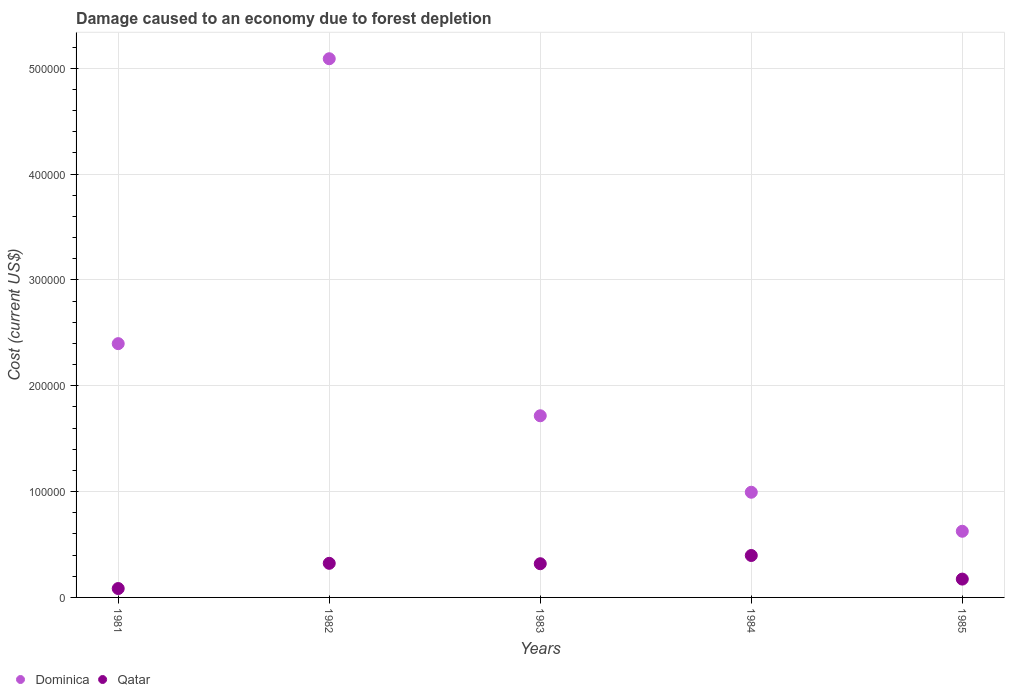How many different coloured dotlines are there?
Offer a very short reply. 2. What is the cost of damage caused due to forest depletion in Dominica in 1985?
Offer a very short reply. 6.25e+04. Across all years, what is the maximum cost of damage caused due to forest depletion in Dominica?
Your answer should be compact. 5.09e+05. Across all years, what is the minimum cost of damage caused due to forest depletion in Qatar?
Give a very brief answer. 8396.44. In which year was the cost of damage caused due to forest depletion in Qatar maximum?
Make the answer very short. 1984. In which year was the cost of damage caused due to forest depletion in Qatar minimum?
Your answer should be compact. 1981. What is the total cost of damage caused due to forest depletion in Dominica in the graph?
Your answer should be compact. 1.08e+06. What is the difference between the cost of damage caused due to forest depletion in Qatar in 1981 and that in 1985?
Offer a very short reply. -8924.05. What is the difference between the cost of damage caused due to forest depletion in Qatar in 1983 and the cost of damage caused due to forest depletion in Dominica in 1981?
Provide a short and direct response. -2.08e+05. What is the average cost of damage caused due to forest depletion in Qatar per year?
Provide a short and direct response. 2.59e+04. In the year 1981, what is the difference between the cost of damage caused due to forest depletion in Qatar and cost of damage caused due to forest depletion in Dominica?
Provide a succinct answer. -2.31e+05. What is the ratio of the cost of damage caused due to forest depletion in Qatar in 1981 to that in 1983?
Your answer should be compact. 0.26. Is the cost of damage caused due to forest depletion in Qatar in 1981 less than that in 1985?
Your answer should be compact. Yes. Is the difference between the cost of damage caused due to forest depletion in Qatar in 1981 and 1985 greater than the difference between the cost of damage caused due to forest depletion in Dominica in 1981 and 1985?
Your answer should be very brief. No. What is the difference between the highest and the second highest cost of damage caused due to forest depletion in Dominica?
Provide a short and direct response. 2.69e+05. What is the difference between the highest and the lowest cost of damage caused due to forest depletion in Dominica?
Your answer should be very brief. 4.46e+05. Is the sum of the cost of damage caused due to forest depletion in Qatar in 1981 and 1985 greater than the maximum cost of damage caused due to forest depletion in Dominica across all years?
Provide a short and direct response. No. Is the cost of damage caused due to forest depletion in Dominica strictly greater than the cost of damage caused due to forest depletion in Qatar over the years?
Keep it short and to the point. Yes. How many dotlines are there?
Ensure brevity in your answer.  2. How many years are there in the graph?
Your response must be concise. 5. How many legend labels are there?
Make the answer very short. 2. What is the title of the graph?
Give a very brief answer. Damage caused to an economy due to forest depletion. What is the label or title of the X-axis?
Your response must be concise. Years. What is the label or title of the Y-axis?
Provide a short and direct response. Cost (current US$). What is the Cost (current US$) of Dominica in 1981?
Give a very brief answer. 2.40e+05. What is the Cost (current US$) in Qatar in 1981?
Give a very brief answer. 8396.44. What is the Cost (current US$) in Dominica in 1982?
Provide a short and direct response. 5.09e+05. What is the Cost (current US$) in Qatar in 1982?
Provide a succinct answer. 3.22e+04. What is the Cost (current US$) of Dominica in 1983?
Provide a short and direct response. 1.72e+05. What is the Cost (current US$) of Qatar in 1983?
Offer a very short reply. 3.18e+04. What is the Cost (current US$) in Dominica in 1984?
Your answer should be compact. 9.94e+04. What is the Cost (current US$) in Qatar in 1984?
Offer a very short reply. 3.96e+04. What is the Cost (current US$) in Dominica in 1985?
Your answer should be very brief. 6.25e+04. What is the Cost (current US$) in Qatar in 1985?
Give a very brief answer. 1.73e+04. Across all years, what is the maximum Cost (current US$) in Dominica?
Offer a very short reply. 5.09e+05. Across all years, what is the maximum Cost (current US$) of Qatar?
Provide a succinct answer. 3.96e+04. Across all years, what is the minimum Cost (current US$) in Dominica?
Your answer should be very brief. 6.25e+04. Across all years, what is the minimum Cost (current US$) of Qatar?
Offer a very short reply. 8396.44. What is the total Cost (current US$) in Dominica in the graph?
Ensure brevity in your answer.  1.08e+06. What is the total Cost (current US$) in Qatar in the graph?
Provide a short and direct response. 1.29e+05. What is the difference between the Cost (current US$) in Dominica in 1981 and that in 1982?
Your answer should be very brief. -2.69e+05. What is the difference between the Cost (current US$) of Qatar in 1981 and that in 1982?
Provide a succinct answer. -2.38e+04. What is the difference between the Cost (current US$) in Dominica in 1981 and that in 1983?
Provide a short and direct response. 6.81e+04. What is the difference between the Cost (current US$) in Qatar in 1981 and that in 1983?
Offer a very short reply. -2.35e+04. What is the difference between the Cost (current US$) in Dominica in 1981 and that in 1984?
Make the answer very short. 1.40e+05. What is the difference between the Cost (current US$) in Qatar in 1981 and that in 1984?
Provide a short and direct response. -3.12e+04. What is the difference between the Cost (current US$) of Dominica in 1981 and that in 1985?
Ensure brevity in your answer.  1.77e+05. What is the difference between the Cost (current US$) of Qatar in 1981 and that in 1985?
Make the answer very short. -8924.05. What is the difference between the Cost (current US$) of Dominica in 1982 and that in 1983?
Your response must be concise. 3.37e+05. What is the difference between the Cost (current US$) in Qatar in 1982 and that in 1983?
Ensure brevity in your answer.  373.74. What is the difference between the Cost (current US$) in Dominica in 1982 and that in 1984?
Ensure brevity in your answer.  4.10e+05. What is the difference between the Cost (current US$) of Qatar in 1982 and that in 1984?
Your response must be concise. -7390.43. What is the difference between the Cost (current US$) of Dominica in 1982 and that in 1985?
Make the answer very short. 4.46e+05. What is the difference between the Cost (current US$) in Qatar in 1982 and that in 1985?
Provide a succinct answer. 1.49e+04. What is the difference between the Cost (current US$) in Dominica in 1983 and that in 1984?
Provide a succinct answer. 7.23e+04. What is the difference between the Cost (current US$) of Qatar in 1983 and that in 1984?
Offer a very short reply. -7764.17. What is the difference between the Cost (current US$) in Dominica in 1983 and that in 1985?
Keep it short and to the point. 1.09e+05. What is the difference between the Cost (current US$) in Qatar in 1983 and that in 1985?
Your answer should be compact. 1.45e+04. What is the difference between the Cost (current US$) of Dominica in 1984 and that in 1985?
Ensure brevity in your answer.  3.69e+04. What is the difference between the Cost (current US$) in Qatar in 1984 and that in 1985?
Provide a succinct answer. 2.23e+04. What is the difference between the Cost (current US$) in Dominica in 1981 and the Cost (current US$) in Qatar in 1982?
Your response must be concise. 2.08e+05. What is the difference between the Cost (current US$) of Dominica in 1981 and the Cost (current US$) of Qatar in 1983?
Offer a terse response. 2.08e+05. What is the difference between the Cost (current US$) of Dominica in 1981 and the Cost (current US$) of Qatar in 1984?
Ensure brevity in your answer.  2.00e+05. What is the difference between the Cost (current US$) in Dominica in 1981 and the Cost (current US$) in Qatar in 1985?
Your response must be concise. 2.22e+05. What is the difference between the Cost (current US$) of Dominica in 1982 and the Cost (current US$) of Qatar in 1983?
Provide a succinct answer. 4.77e+05. What is the difference between the Cost (current US$) of Dominica in 1982 and the Cost (current US$) of Qatar in 1984?
Your answer should be compact. 4.69e+05. What is the difference between the Cost (current US$) of Dominica in 1982 and the Cost (current US$) of Qatar in 1985?
Make the answer very short. 4.92e+05. What is the difference between the Cost (current US$) of Dominica in 1983 and the Cost (current US$) of Qatar in 1984?
Your answer should be very brief. 1.32e+05. What is the difference between the Cost (current US$) of Dominica in 1983 and the Cost (current US$) of Qatar in 1985?
Ensure brevity in your answer.  1.54e+05. What is the difference between the Cost (current US$) of Dominica in 1984 and the Cost (current US$) of Qatar in 1985?
Ensure brevity in your answer.  8.21e+04. What is the average Cost (current US$) of Dominica per year?
Your response must be concise. 2.16e+05. What is the average Cost (current US$) in Qatar per year?
Give a very brief answer. 2.59e+04. In the year 1981, what is the difference between the Cost (current US$) of Dominica and Cost (current US$) of Qatar?
Your answer should be compact. 2.31e+05. In the year 1982, what is the difference between the Cost (current US$) in Dominica and Cost (current US$) in Qatar?
Provide a succinct answer. 4.77e+05. In the year 1983, what is the difference between the Cost (current US$) of Dominica and Cost (current US$) of Qatar?
Give a very brief answer. 1.40e+05. In the year 1984, what is the difference between the Cost (current US$) of Dominica and Cost (current US$) of Qatar?
Your response must be concise. 5.98e+04. In the year 1985, what is the difference between the Cost (current US$) of Dominica and Cost (current US$) of Qatar?
Give a very brief answer. 4.52e+04. What is the ratio of the Cost (current US$) in Dominica in 1981 to that in 1982?
Make the answer very short. 0.47. What is the ratio of the Cost (current US$) in Qatar in 1981 to that in 1982?
Give a very brief answer. 0.26. What is the ratio of the Cost (current US$) of Dominica in 1981 to that in 1983?
Your answer should be very brief. 1.4. What is the ratio of the Cost (current US$) of Qatar in 1981 to that in 1983?
Give a very brief answer. 0.26. What is the ratio of the Cost (current US$) in Dominica in 1981 to that in 1984?
Provide a short and direct response. 2.41. What is the ratio of the Cost (current US$) in Qatar in 1981 to that in 1984?
Offer a very short reply. 0.21. What is the ratio of the Cost (current US$) in Dominica in 1981 to that in 1985?
Make the answer very short. 3.84. What is the ratio of the Cost (current US$) in Qatar in 1981 to that in 1985?
Offer a very short reply. 0.48. What is the ratio of the Cost (current US$) in Dominica in 1982 to that in 1983?
Provide a short and direct response. 2.97. What is the ratio of the Cost (current US$) of Qatar in 1982 to that in 1983?
Make the answer very short. 1.01. What is the ratio of the Cost (current US$) in Dominica in 1982 to that in 1984?
Your answer should be very brief. 5.12. What is the ratio of the Cost (current US$) in Qatar in 1982 to that in 1984?
Provide a succinct answer. 0.81. What is the ratio of the Cost (current US$) in Dominica in 1982 to that in 1985?
Keep it short and to the point. 8.14. What is the ratio of the Cost (current US$) of Qatar in 1982 to that in 1985?
Provide a short and direct response. 1.86. What is the ratio of the Cost (current US$) of Dominica in 1983 to that in 1984?
Keep it short and to the point. 1.73. What is the ratio of the Cost (current US$) in Qatar in 1983 to that in 1984?
Give a very brief answer. 0.8. What is the ratio of the Cost (current US$) of Dominica in 1983 to that in 1985?
Keep it short and to the point. 2.75. What is the ratio of the Cost (current US$) of Qatar in 1983 to that in 1985?
Offer a very short reply. 1.84. What is the ratio of the Cost (current US$) in Dominica in 1984 to that in 1985?
Ensure brevity in your answer.  1.59. What is the ratio of the Cost (current US$) of Qatar in 1984 to that in 1985?
Your answer should be compact. 2.29. What is the difference between the highest and the second highest Cost (current US$) of Dominica?
Offer a very short reply. 2.69e+05. What is the difference between the highest and the second highest Cost (current US$) of Qatar?
Your answer should be very brief. 7390.43. What is the difference between the highest and the lowest Cost (current US$) in Dominica?
Provide a short and direct response. 4.46e+05. What is the difference between the highest and the lowest Cost (current US$) of Qatar?
Your answer should be very brief. 3.12e+04. 